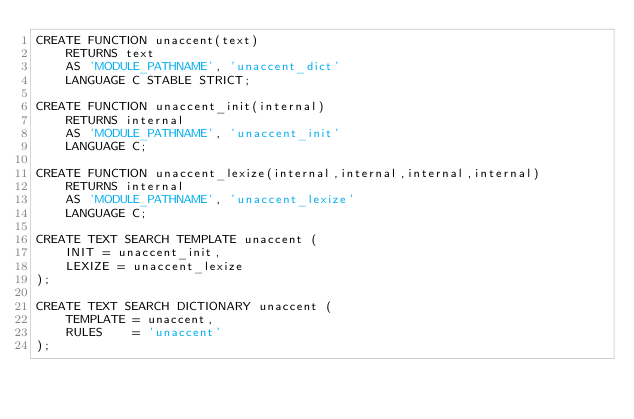Convert code to text. <code><loc_0><loc_0><loc_500><loc_500><_SQL_>CREATE FUNCTION unaccent(text)
	RETURNS text
	AS 'MODULE_PATHNAME', 'unaccent_dict'
	LANGUAGE C STABLE STRICT;

CREATE FUNCTION unaccent_init(internal)
	RETURNS internal
	AS 'MODULE_PATHNAME', 'unaccent_init'
	LANGUAGE C;

CREATE FUNCTION unaccent_lexize(internal,internal,internal,internal)
	RETURNS internal
	AS 'MODULE_PATHNAME', 'unaccent_lexize'
	LANGUAGE C;

CREATE TEXT SEARCH TEMPLATE unaccent (
	INIT = unaccent_init,
	LEXIZE = unaccent_lexize
);

CREATE TEXT SEARCH DICTIONARY unaccent (
	TEMPLATE = unaccent,
	RULES    = 'unaccent'
);
</code> 